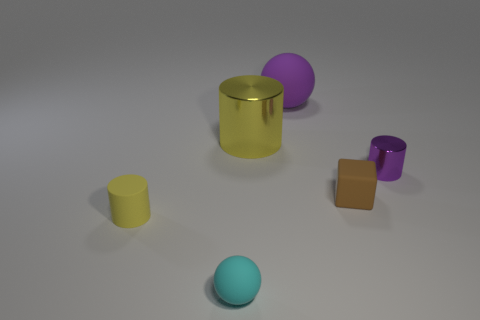Which objects in this image could likely hold the same volume of content? Given their shapes and sizes, the yellow cylinder seems large enough to hold possibly the same volume as the combined volume of the small yellow cylinder and the purple cube. However, without exact dimensions, this is an estimate based on their relative sizes and proportions in the image. 